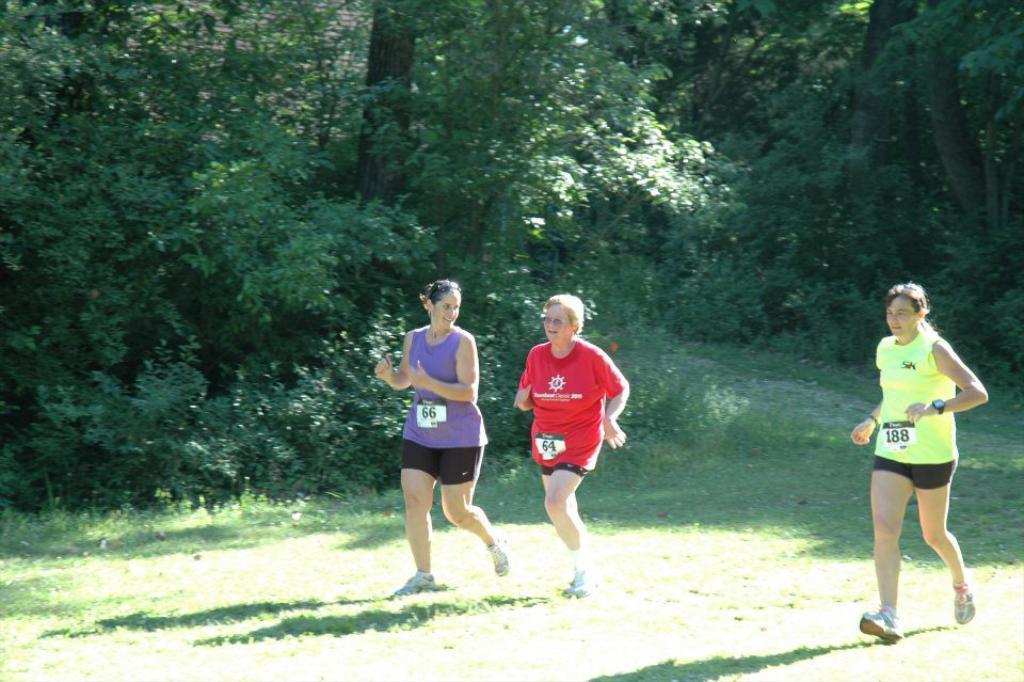How would you summarize this image in a sentence or two? There are people in the foreground area of the image, it seems like jogging on the grassland and trees in the background. 